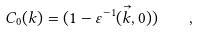<formula> <loc_0><loc_0><loc_500><loc_500>C _ { 0 } ( k ) = ( 1 - \varepsilon ^ { - 1 } ( \vec { k } , 0 ) ) \quad ,</formula> 